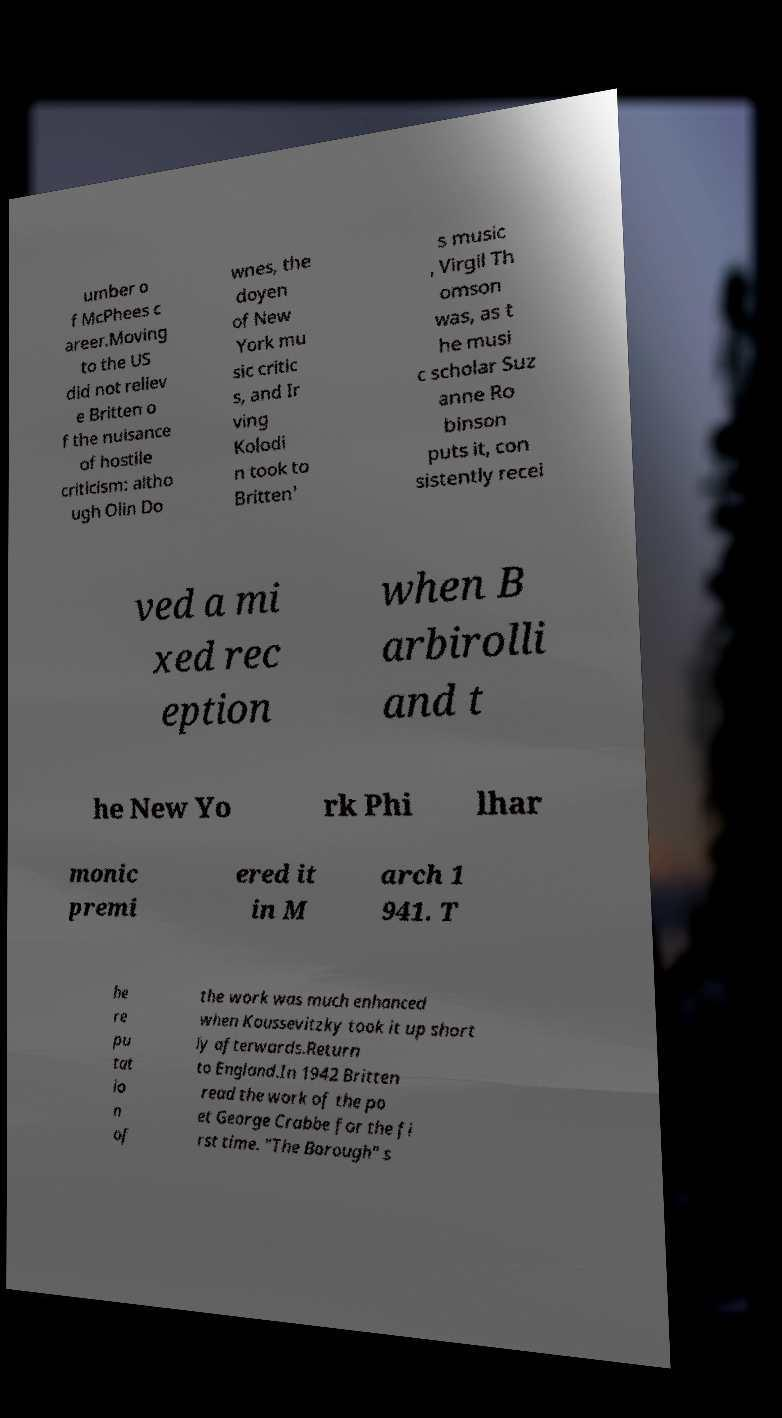Please read and relay the text visible in this image. What does it say? umber o f McPhees c areer.Moving to the US did not reliev e Britten o f the nuisance of hostile criticism: altho ugh Olin Do wnes, the doyen of New York mu sic critic s, and Ir ving Kolodi n took to Britten' s music , Virgil Th omson was, as t he musi c scholar Suz anne Ro binson puts it, con sistently recei ved a mi xed rec eption when B arbirolli and t he New Yo rk Phi lhar monic premi ered it in M arch 1 941. T he re pu tat io n of the work was much enhanced when Koussevitzky took it up short ly afterwards.Return to England.In 1942 Britten read the work of the po et George Crabbe for the fi rst time. "The Borough" s 